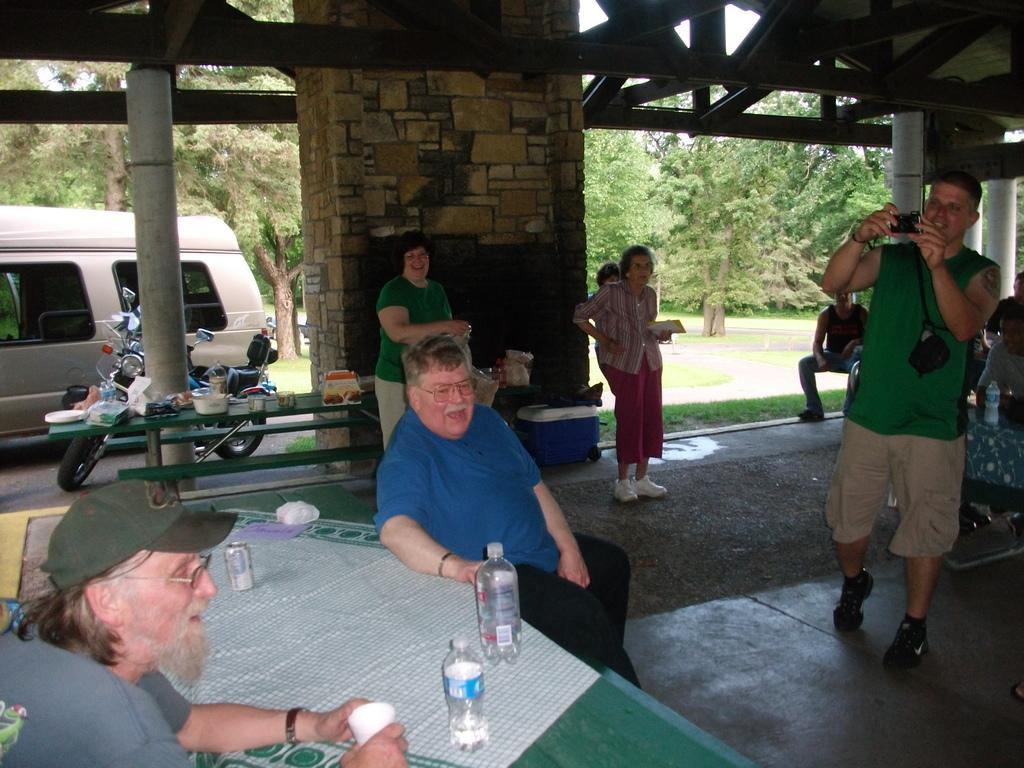Please provide a concise description of this image. In the given image i can see a people,table,bottles,vehicles,wall and in the background i can see the trees. 